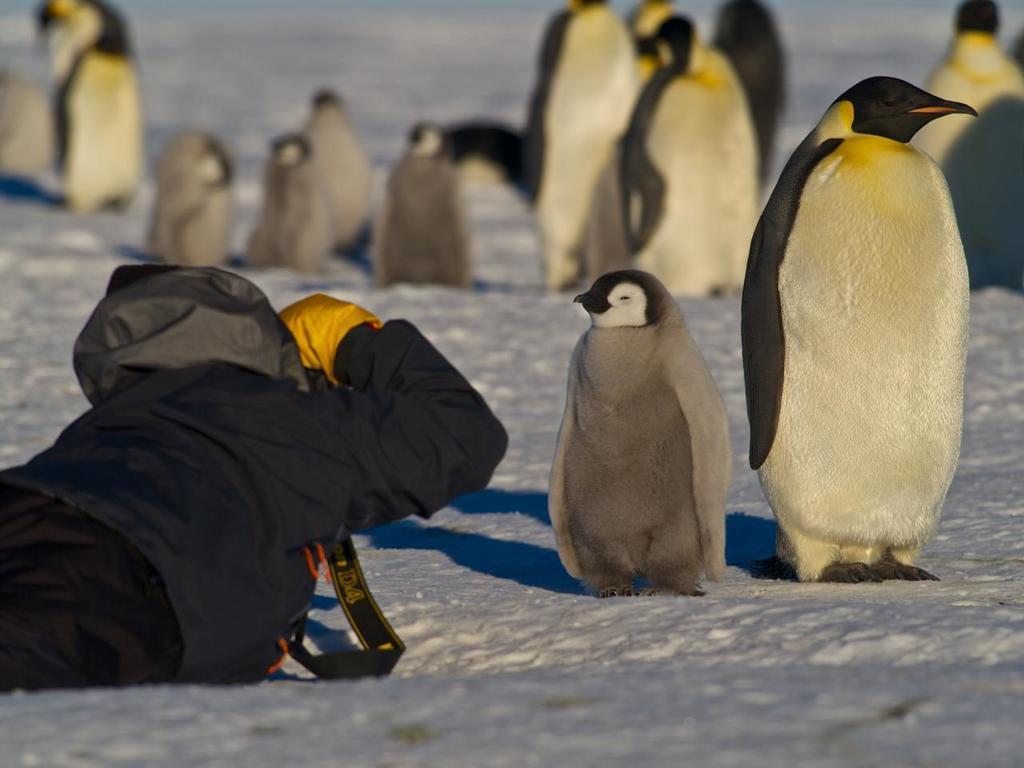In one or two sentences, can you explain what this image depicts? In this image there is one person is at left side of this image is holding a camera and there are some penguins at right side of this image and top of this image and there is a ground as we can see in the background. 